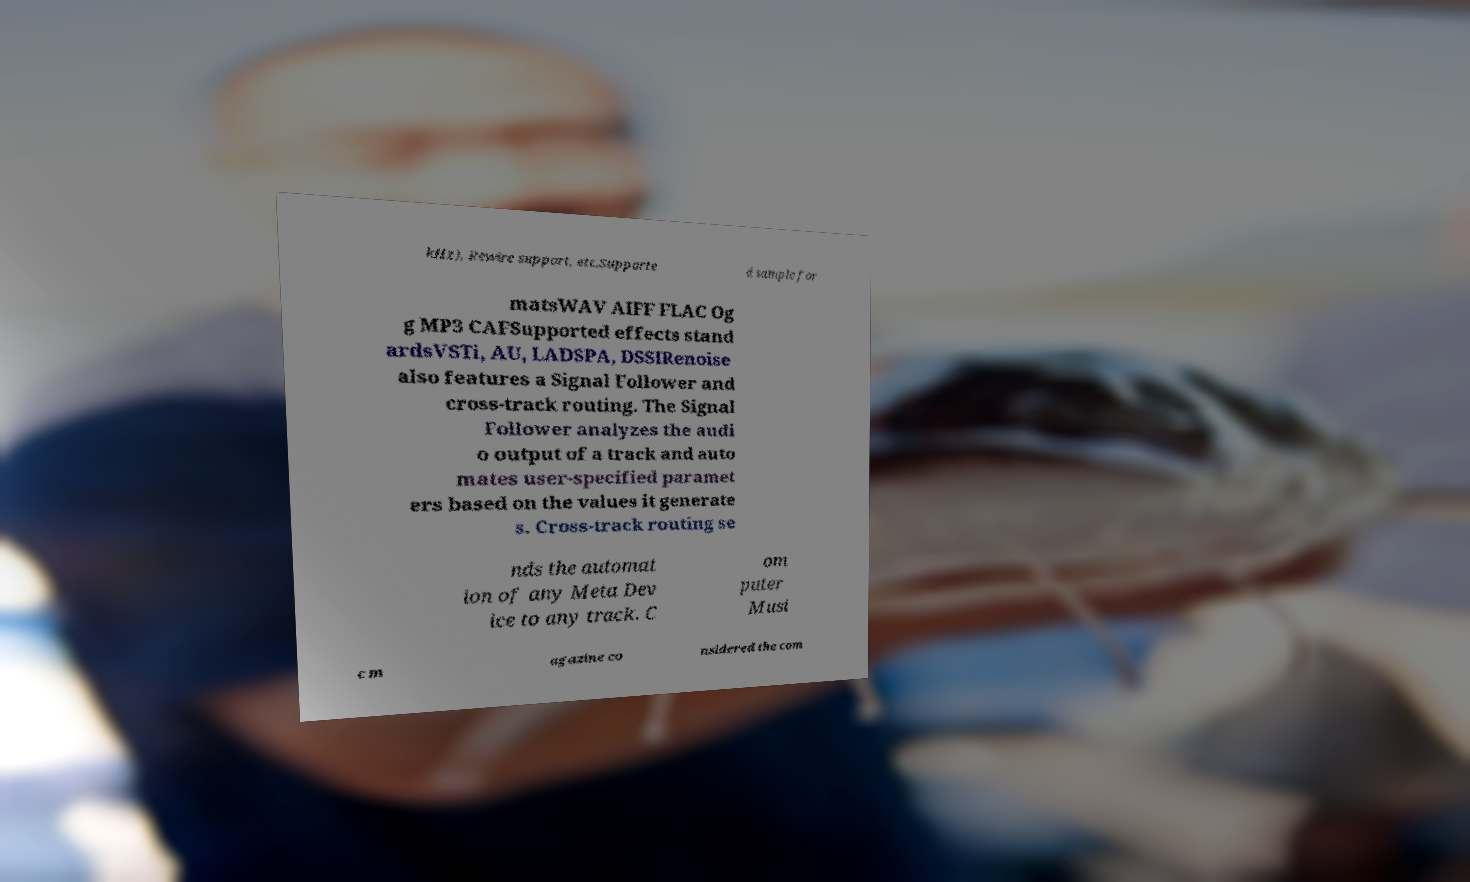I need the written content from this picture converted into text. Can you do that? kHz), Rewire support, etc.Supporte d sample for matsWAV AIFF FLAC Og g MP3 CAFSupported effects stand ardsVSTi, AU, LADSPA, DSSIRenoise also features a Signal Follower and cross-track routing. The Signal Follower analyzes the audi o output of a track and auto mates user-specified paramet ers based on the values it generate s. Cross-track routing se nds the automat ion of any Meta Dev ice to any track. C om puter Musi c m agazine co nsidered the com 